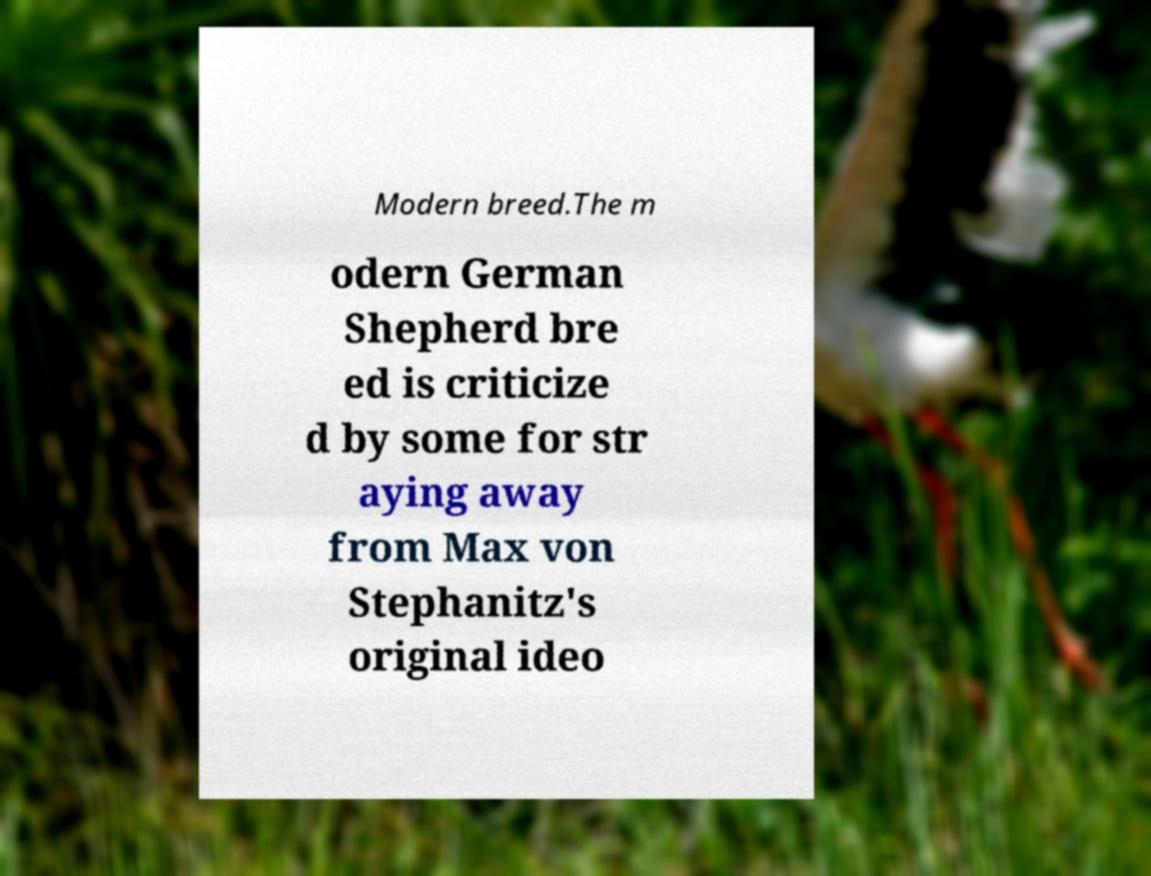What messages or text are displayed in this image? I need them in a readable, typed format. Modern breed.The m odern German Shepherd bre ed is criticize d by some for str aying away from Max von Stephanitz's original ideo 